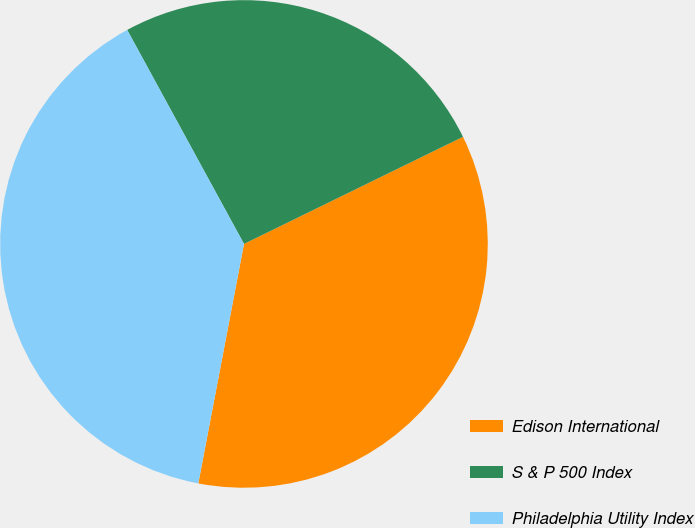<chart> <loc_0><loc_0><loc_500><loc_500><pie_chart><fcel>Edison International<fcel>S & P 500 Index<fcel>Philadelphia Utility Index<nl><fcel>35.24%<fcel>25.71%<fcel>39.05%<nl></chart> 